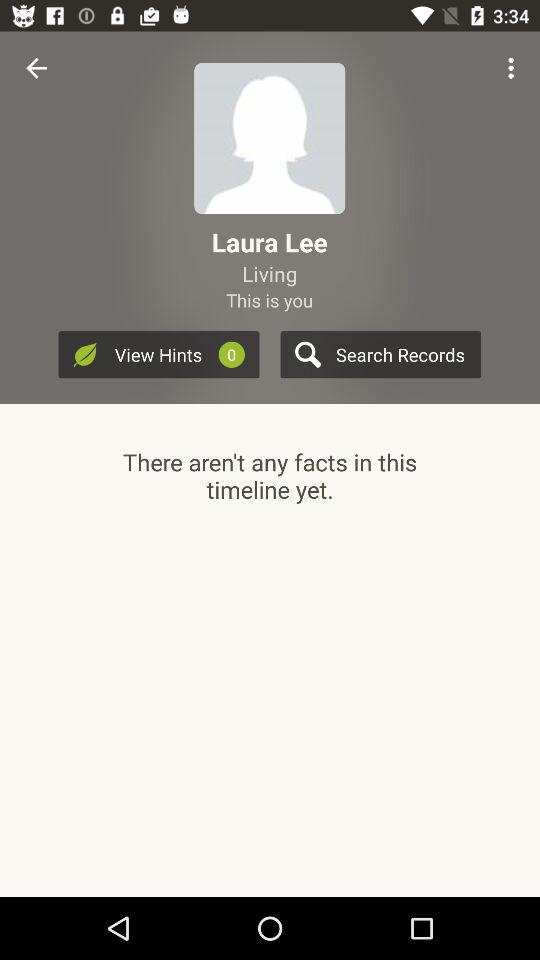What is the count of "View Hints"? The count of "View Hints" is 0. 